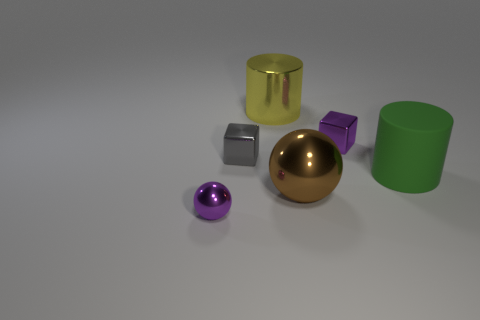Add 4 green cylinders. How many objects exist? 10 Subtract 1 cylinders. How many cylinders are left? 1 Subtract all small gray metallic cubes. Subtract all large red matte balls. How many objects are left? 5 Add 1 small purple blocks. How many small purple blocks are left? 2 Add 5 large rubber cylinders. How many large rubber cylinders exist? 6 Subtract 0 cyan spheres. How many objects are left? 6 Subtract all cylinders. How many objects are left? 4 